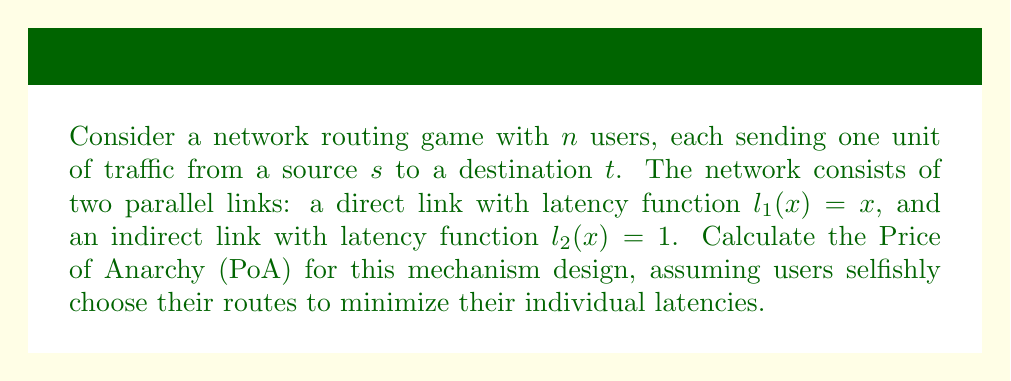Could you help me with this problem? To solve this problem, we'll follow these steps:

1) First, let's identify the Nash equilibrium of this game:
   - If $x$ users choose the direct link, their latency is $x$.
   - The latency on the indirect link is always 1.
   - In equilibrium, these must be equal: $x = 1$
   - So, in the Nash equilibrium, 1 user takes the direct link, and $n-1$ users take the indirect link.

2) Now, let's calculate the social cost at this Nash equilibrium:
   $C_{NE} = 1 \cdot 1 + (n-1) \cdot 1 = n$

3) Next, we need to find the optimal (minimum) social cost:
   - If $x$ users take the direct link, the social cost is:
     $C(x) = x \cdot x + (n-x) \cdot 1 = x^2 + n - x$
   - To minimize this, we differentiate and set to zero:
     $\frac{dC}{dx} = 2x - 1 = 0$
     $x = \frac{1}{2}$
   - The optimal allocation is to send $\frac{1}{2}$ user through the direct link and $n - \frac{1}{2}$ through the indirect link.

4) The optimal social cost is thus:
   $C_{OPT} = \frac{1}{2} \cdot \frac{1}{2} + (n - \frac{1}{2}) \cdot 1 = \frac{1}{4} + n - \frac{1}{2} = n - \frac{1}{4}$

5) The Price of Anarchy is defined as the ratio of the worst-case Nash equilibrium cost to the optimal cost:

   $PoA = \frac{C_{NE}}{C_{OPT}} = \frac{n}{n - \frac{1}{4}}$

6) As $n$ approaches infinity, this ratio approaches 1. For any finite $n$, it's slightly larger than 1.

7) To simplify, we can write:
   $PoA = \frac{4n}{4n - 1}$
Answer: The Price of Anarchy for this network routing game is $\frac{4n}{4n - 1}$. 